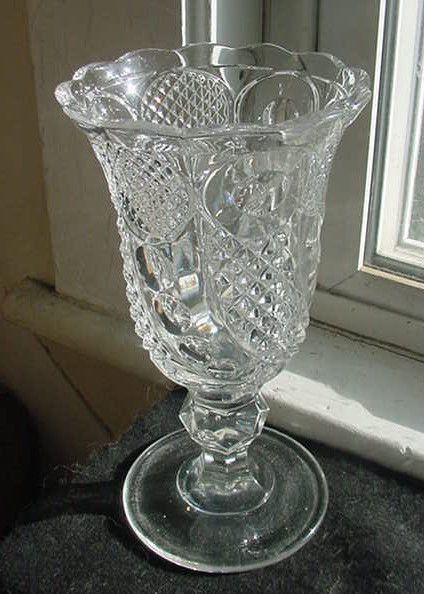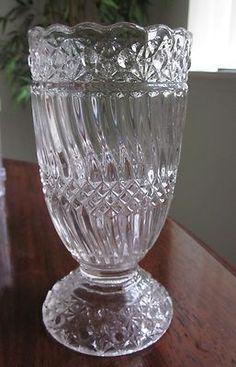The first image is the image on the left, the second image is the image on the right. Assess this claim about the two images: "One of the goblets has a curled tail.". Correct or not? Answer yes or no. No. The first image is the image on the left, the second image is the image on the right. Analyze the images presented: Is the assertion "An image shows a vase with a curl like an ocean wave at the bottom." valid? Answer yes or no. No. 